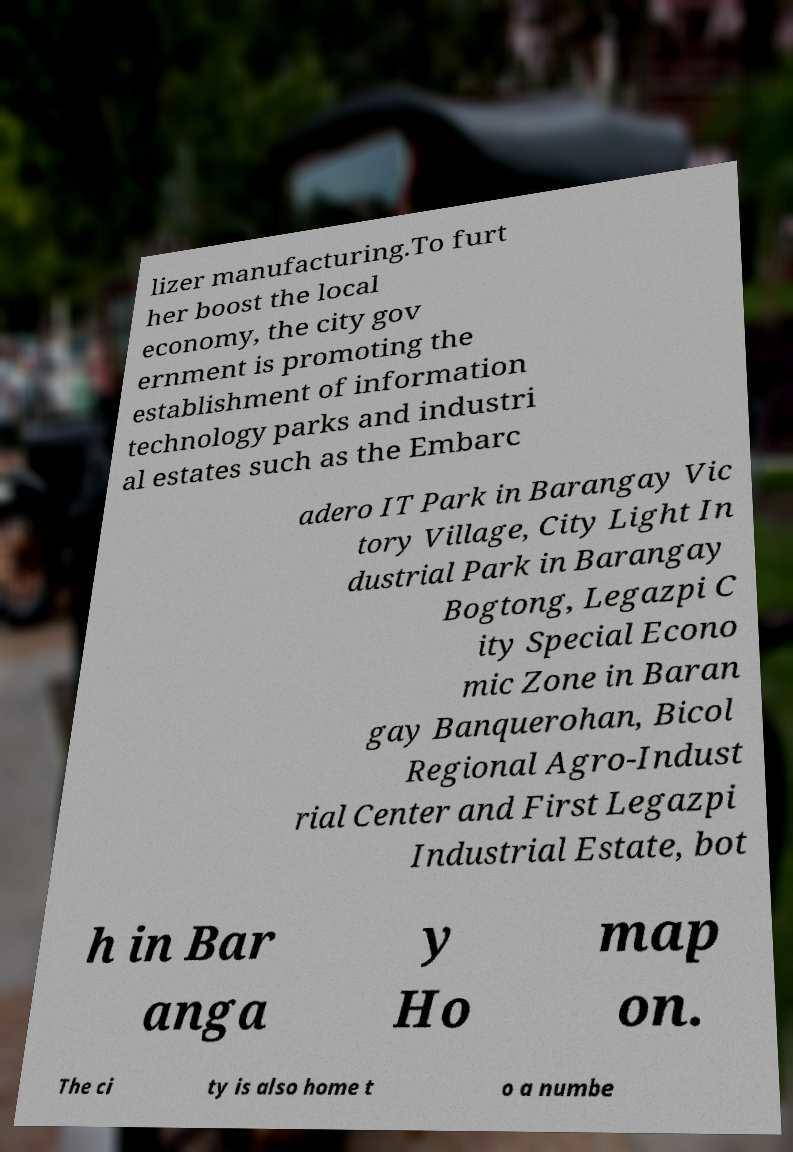Can you read and provide the text displayed in the image?This photo seems to have some interesting text. Can you extract and type it out for me? lizer manufacturing.To furt her boost the local economy, the city gov ernment is promoting the establishment of information technology parks and industri al estates such as the Embarc adero IT Park in Barangay Vic tory Village, City Light In dustrial Park in Barangay Bogtong, Legazpi C ity Special Econo mic Zone in Baran gay Banquerohan, Bicol Regional Agro-Indust rial Center and First Legazpi Industrial Estate, bot h in Bar anga y Ho map on. The ci ty is also home t o a numbe 